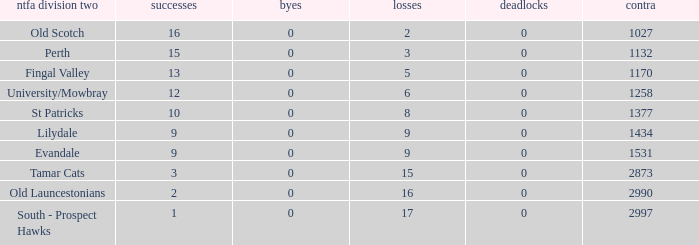What is the lowest number of against of NTFA Div 2 Fingal Valley? 1170.0. 